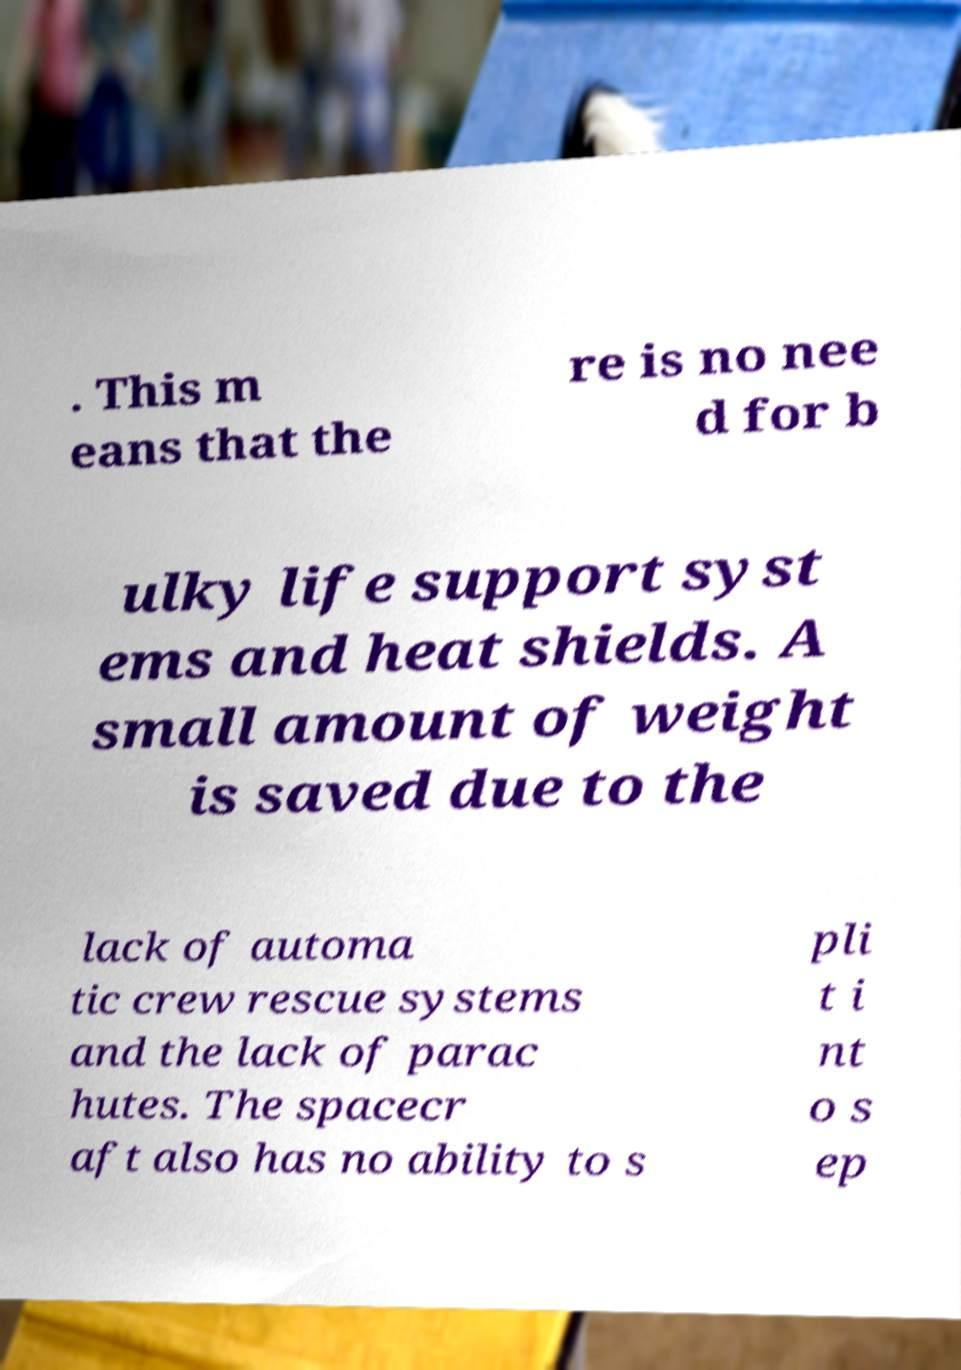I need the written content from this picture converted into text. Can you do that? . This m eans that the re is no nee d for b ulky life support syst ems and heat shields. A small amount of weight is saved due to the lack of automa tic crew rescue systems and the lack of parac hutes. The spacecr aft also has no ability to s pli t i nt o s ep 